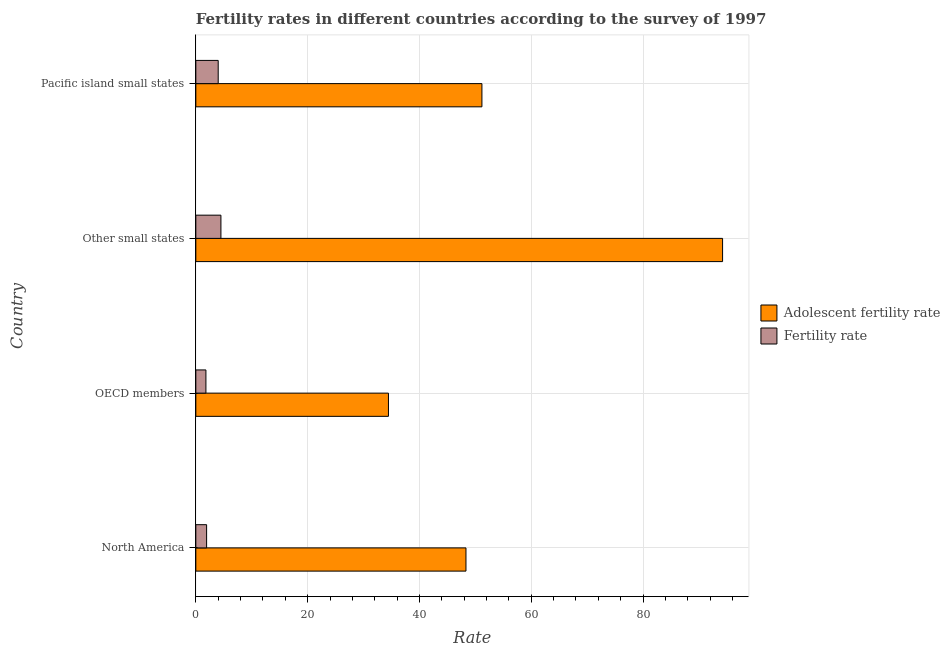How many different coloured bars are there?
Make the answer very short. 2. How many groups of bars are there?
Ensure brevity in your answer.  4. Are the number of bars per tick equal to the number of legend labels?
Make the answer very short. Yes. Are the number of bars on each tick of the Y-axis equal?
Ensure brevity in your answer.  Yes. How many bars are there on the 1st tick from the top?
Offer a very short reply. 2. How many bars are there on the 2nd tick from the bottom?
Ensure brevity in your answer.  2. What is the label of the 3rd group of bars from the top?
Your response must be concise. OECD members. In how many cases, is the number of bars for a given country not equal to the number of legend labels?
Your answer should be compact. 0. What is the adolescent fertility rate in North America?
Make the answer very short. 48.32. Across all countries, what is the maximum adolescent fertility rate?
Ensure brevity in your answer.  94.23. Across all countries, what is the minimum adolescent fertility rate?
Offer a terse response. 34.46. In which country was the fertility rate maximum?
Your answer should be compact. Other small states. In which country was the fertility rate minimum?
Keep it short and to the point. OECD members. What is the total adolescent fertility rate in the graph?
Ensure brevity in your answer.  228.18. What is the difference between the fertility rate in Other small states and that in Pacific island small states?
Keep it short and to the point. 0.49. What is the difference between the fertility rate in OECD members and the adolescent fertility rate in North America?
Make the answer very short. -46.52. What is the average fertility rate per country?
Provide a short and direct response. 3.06. What is the difference between the fertility rate and adolescent fertility rate in North America?
Provide a succinct answer. -46.4. What is the ratio of the fertility rate in North America to that in Pacific island small states?
Your response must be concise. 0.48. Is the adolescent fertility rate in North America less than that in OECD members?
Keep it short and to the point. No. What is the difference between the highest and the second highest adolescent fertility rate?
Ensure brevity in your answer.  43.05. What is the difference between the highest and the lowest adolescent fertility rate?
Provide a short and direct response. 59.77. What does the 1st bar from the top in North America represents?
Ensure brevity in your answer.  Fertility rate. What does the 2nd bar from the bottom in OECD members represents?
Ensure brevity in your answer.  Fertility rate. How many bars are there?
Give a very brief answer. 8. Are all the bars in the graph horizontal?
Ensure brevity in your answer.  Yes. Are the values on the major ticks of X-axis written in scientific E-notation?
Offer a very short reply. No. Does the graph contain any zero values?
Provide a succinct answer. No. Where does the legend appear in the graph?
Your answer should be compact. Center right. How many legend labels are there?
Provide a succinct answer. 2. How are the legend labels stacked?
Offer a terse response. Vertical. What is the title of the graph?
Give a very brief answer. Fertility rates in different countries according to the survey of 1997. Does "Quasi money growth" appear as one of the legend labels in the graph?
Ensure brevity in your answer.  No. What is the label or title of the X-axis?
Your response must be concise. Rate. What is the label or title of the Y-axis?
Give a very brief answer. Country. What is the Rate of Adolescent fertility rate in North America?
Give a very brief answer. 48.32. What is the Rate in Fertility rate in North America?
Give a very brief answer. 1.93. What is the Rate of Adolescent fertility rate in OECD members?
Make the answer very short. 34.46. What is the Rate in Fertility rate in OECD members?
Offer a very short reply. 1.81. What is the Rate in Adolescent fertility rate in Other small states?
Ensure brevity in your answer.  94.23. What is the Rate in Fertility rate in Other small states?
Provide a succinct answer. 4.49. What is the Rate in Adolescent fertility rate in Pacific island small states?
Your response must be concise. 51.18. What is the Rate in Fertility rate in Pacific island small states?
Make the answer very short. 4. Across all countries, what is the maximum Rate in Adolescent fertility rate?
Provide a short and direct response. 94.23. Across all countries, what is the maximum Rate in Fertility rate?
Offer a very short reply. 4.49. Across all countries, what is the minimum Rate of Adolescent fertility rate?
Ensure brevity in your answer.  34.46. Across all countries, what is the minimum Rate of Fertility rate?
Offer a very short reply. 1.81. What is the total Rate of Adolescent fertility rate in the graph?
Ensure brevity in your answer.  228.19. What is the total Rate in Fertility rate in the graph?
Keep it short and to the point. 12.22. What is the difference between the Rate in Adolescent fertility rate in North America and that in OECD members?
Your answer should be very brief. 13.87. What is the difference between the Rate of Fertility rate in North America and that in OECD members?
Offer a very short reply. 0.12. What is the difference between the Rate of Adolescent fertility rate in North America and that in Other small states?
Offer a terse response. -45.9. What is the difference between the Rate of Fertility rate in North America and that in Other small states?
Provide a succinct answer. -2.56. What is the difference between the Rate in Adolescent fertility rate in North America and that in Pacific island small states?
Offer a very short reply. -2.85. What is the difference between the Rate in Fertility rate in North America and that in Pacific island small states?
Your response must be concise. -2.07. What is the difference between the Rate of Adolescent fertility rate in OECD members and that in Other small states?
Keep it short and to the point. -59.77. What is the difference between the Rate in Fertility rate in OECD members and that in Other small states?
Provide a short and direct response. -2.68. What is the difference between the Rate in Adolescent fertility rate in OECD members and that in Pacific island small states?
Keep it short and to the point. -16.72. What is the difference between the Rate of Fertility rate in OECD members and that in Pacific island small states?
Provide a short and direct response. -2.2. What is the difference between the Rate in Adolescent fertility rate in Other small states and that in Pacific island small states?
Ensure brevity in your answer.  43.05. What is the difference between the Rate in Fertility rate in Other small states and that in Pacific island small states?
Provide a succinct answer. 0.49. What is the difference between the Rate in Adolescent fertility rate in North America and the Rate in Fertility rate in OECD members?
Your answer should be compact. 46.52. What is the difference between the Rate in Adolescent fertility rate in North America and the Rate in Fertility rate in Other small states?
Make the answer very short. 43.84. What is the difference between the Rate of Adolescent fertility rate in North America and the Rate of Fertility rate in Pacific island small states?
Provide a succinct answer. 44.32. What is the difference between the Rate of Adolescent fertility rate in OECD members and the Rate of Fertility rate in Other small states?
Make the answer very short. 29.97. What is the difference between the Rate of Adolescent fertility rate in OECD members and the Rate of Fertility rate in Pacific island small states?
Your response must be concise. 30.46. What is the difference between the Rate in Adolescent fertility rate in Other small states and the Rate in Fertility rate in Pacific island small states?
Keep it short and to the point. 90.22. What is the average Rate of Adolescent fertility rate per country?
Provide a succinct answer. 57.05. What is the average Rate in Fertility rate per country?
Give a very brief answer. 3.06. What is the difference between the Rate of Adolescent fertility rate and Rate of Fertility rate in North America?
Offer a very short reply. 46.4. What is the difference between the Rate of Adolescent fertility rate and Rate of Fertility rate in OECD members?
Make the answer very short. 32.65. What is the difference between the Rate in Adolescent fertility rate and Rate in Fertility rate in Other small states?
Your answer should be compact. 89.74. What is the difference between the Rate of Adolescent fertility rate and Rate of Fertility rate in Pacific island small states?
Offer a very short reply. 47.17. What is the ratio of the Rate of Adolescent fertility rate in North America to that in OECD members?
Provide a succinct answer. 1.4. What is the ratio of the Rate in Fertility rate in North America to that in OECD members?
Provide a short and direct response. 1.07. What is the ratio of the Rate of Adolescent fertility rate in North America to that in Other small states?
Ensure brevity in your answer.  0.51. What is the ratio of the Rate of Fertility rate in North America to that in Other small states?
Provide a succinct answer. 0.43. What is the ratio of the Rate in Adolescent fertility rate in North America to that in Pacific island small states?
Your response must be concise. 0.94. What is the ratio of the Rate of Fertility rate in North America to that in Pacific island small states?
Keep it short and to the point. 0.48. What is the ratio of the Rate in Adolescent fertility rate in OECD members to that in Other small states?
Make the answer very short. 0.37. What is the ratio of the Rate of Fertility rate in OECD members to that in Other small states?
Keep it short and to the point. 0.4. What is the ratio of the Rate of Adolescent fertility rate in OECD members to that in Pacific island small states?
Your answer should be very brief. 0.67. What is the ratio of the Rate of Fertility rate in OECD members to that in Pacific island small states?
Give a very brief answer. 0.45. What is the ratio of the Rate of Adolescent fertility rate in Other small states to that in Pacific island small states?
Provide a succinct answer. 1.84. What is the ratio of the Rate of Fertility rate in Other small states to that in Pacific island small states?
Your response must be concise. 1.12. What is the difference between the highest and the second highest Rate in Adolescent fertility rate?
Give a very brief answer. 43.05. What is the difference between the highest and the second highest Rate of Fertility rate?
Ensure brevity in your answer.  0.49. What is the difference between the highest and the lowest Rate of Adolescent fertility rate?
Keep it short and to the point. 59.77. What is the difference between the highest and the lowest Rate in Fertility rate?
Your answer should be compact. 2.68. 